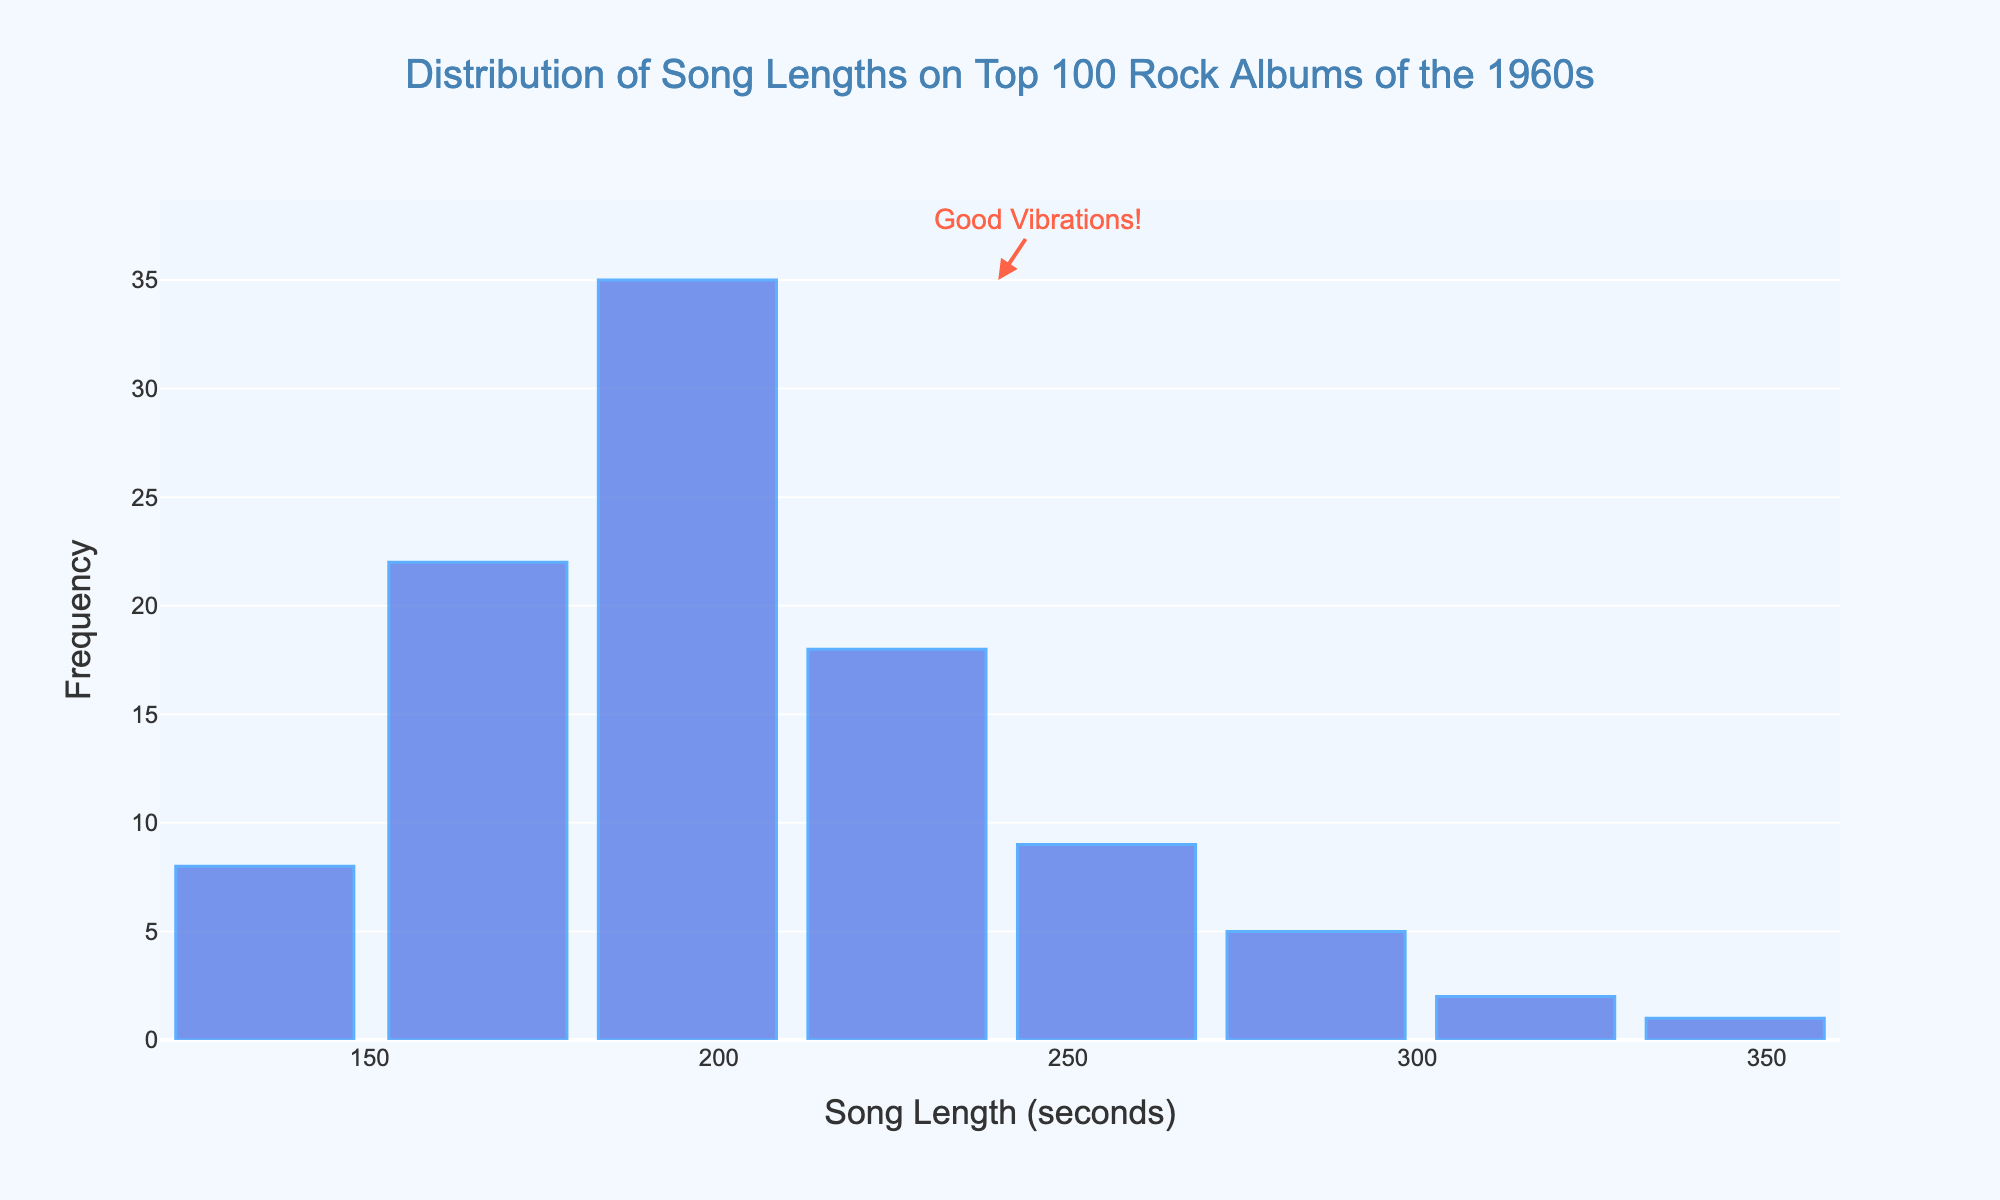Which song length range has the highest frequency? The highest bar represents the song length range with the highest frequency. In the figure, the bar centered around 195 seconds (151-210 seconds) is the tallest.
Answer: 181-210 seconds How many songs have lengths between 120 and 180 seconds? To find this, add the frequencies of the relevant song length ranges: 120-150 seconds (8) and 151-180 seconds (22). The total is 8 + 22.
Answer: 30 Which song length range has the lowest frequency? The shortest bar in the figure indicates the song length range with the lowest frequency. In the figure, the bar centered around 345 seconds (331-360 seconds) is the shortest.
Answer: 331-360 seconds What is the total number of songs represented in the histogram? Add the frequencies of all song length ranges: 8 + 22 + 35 + 18 + 9 + 5 + 2 + 1. The total is 100.
Answer: 100 How many more songs are there in the 181-210 seconds range compared to the 211-240 seconds range? Subtract the frequency of the 211-240 seconds range (18) from the frequency of the 181-210 seconds range (35). The difference is 35 - 18.
Answer: 17 What is the average frequency of songs in all the length ranges? The average frequency is calculated by dividing the total number of songs (100) by the number of length ranges (8). The average is 100 / 8.
Answer: 12.5 Is the number of songs in the 181-210 seconds range greater than the sum of songs in the 241-270 and 271-300 seconds ranges? Compare the frequency of the 181-210 seconds range (35) to the sum of frequencies of the 241-270 (9) and 271-300 (5) ranges: 9 + 5 = 14. Since 35 > 14, the answer is yes.
Answer: Yes How many song length ranges have a frequency greater than 10? Identify bars taller than the 10 mark on the y-axis: 151-180 seconds (22), 181-210 seconds (35), and 211-240 seconds (18). These are 3 ranges.
Answer: 3 What is the range of the most common song length range in the histogram? The "most common range" refers to the range with the highest frequency, which is 181-210 seconds.
Answer: 181-210 seconds 